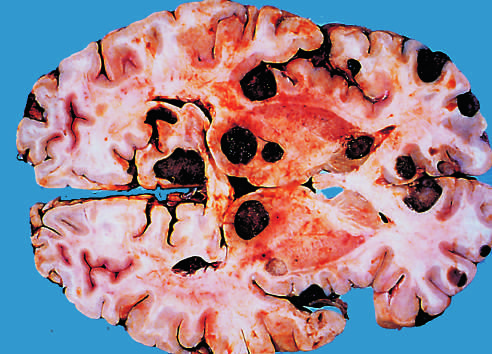by whose multicentricity are metastatic lesions distinguished grossly from most primary central nervous system tumors?
Answer the question using a single word or phrase. Metastatic grossly from most primary central nervous system tumors by their and well-demarcated margins 